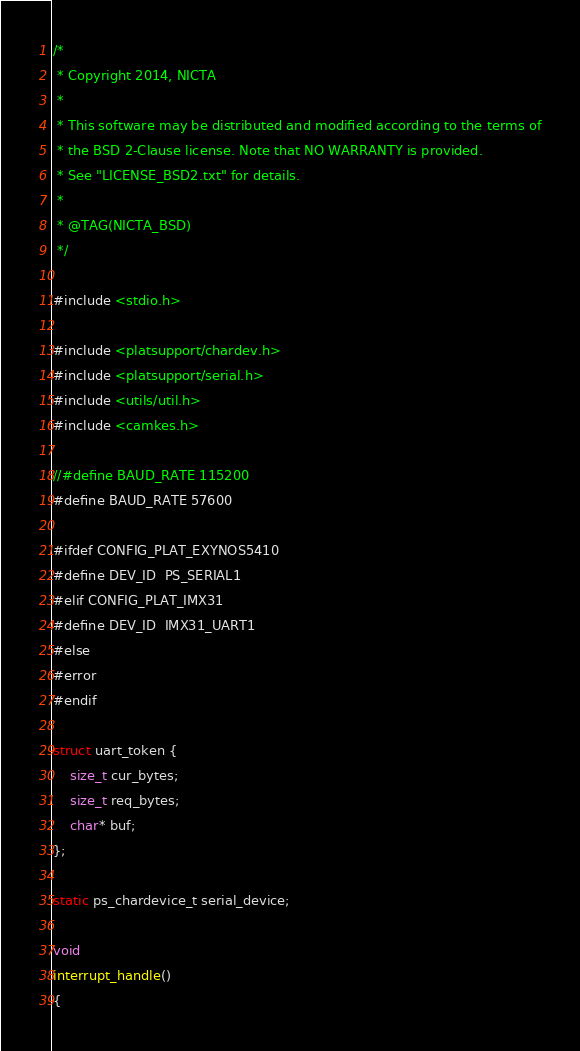Convert code to text. <code><loc_0><loc_0><loc_500><loc_500><_C_>/*
 * Copyright 2014, NICTA
 *
 * This software may be distributed and modified according to the terms of
 * the BSD 2-Clause license. Note that NO WARRANTY is provided.
 * See "LICENSE_BSD2.txt" for details.
 *
 * @TAG(NICTA_BSD)
 */

#include <stdio.h>

#include <platsupport/chardev.h>
#include <platsupport/serial.h>
#include <utils/util.h>
#include <camkes.h>

//#define BAUD_RATE 115200
#define BAUD_RATE 57600

#ifdef CONFIG_PLAT_EXYNOS5410
#define DEV_ID  PS_SERIAL1
#elif CONFIG_PLAT_IMX31
#define DEV_ID  IMX31_UART1
#else
#error
#endif

struct uart_token {
    size_t cur_bytes;
    size_t req_bytes;
    char* buf;
};

static ps_chardevice_t serial_device;

void
interrupt_handle()
{</code> 